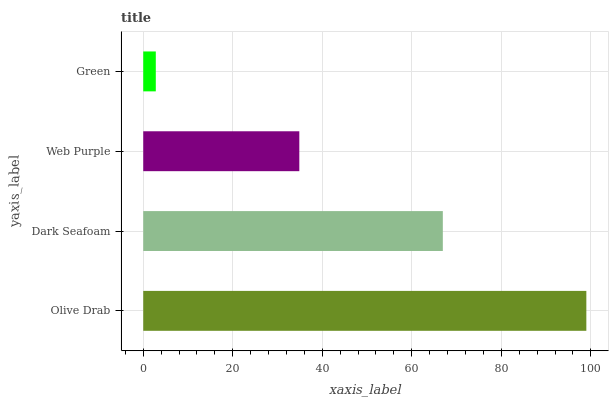Is Green the minimum?
Answer yes or no. Yes. Is Olive Drab the maximum?
Answer yes or no. Yes. Is Dark Seafoam the minimum?
Answer yes or no. No. Is Dark Seafoam the maximum?
Answer yes or no. No. Is Olive Drab greater than Dark Seafoam?
Answer yes or no. Yes. Is Dark Seafoam less than Olive Drab?
Answer yes or no. Yes. Is Dark Seafoam greater than Olive Drab?
Answer yes or no. No. Is Olive Drab less than Dark Seafoam?
Answer yes or no. No. Is Dark Seafoam the high median?
Answer yes or no. Yes. Is Web Purple the low median?
Answer yes or no. Yes. Is Olive Drab the high median?
Answer yes or no. No. Is Olive Drab the low median?
Answer yes or no. No. 